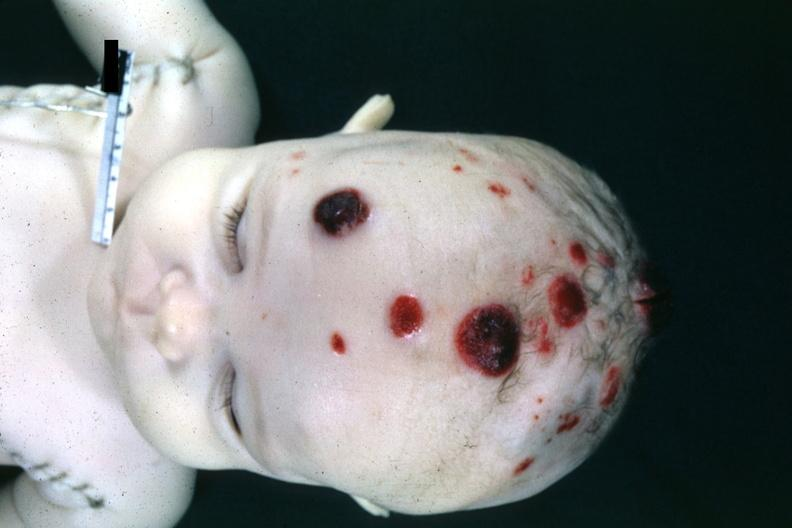s coronary atherosclerosis present?
Answer the question using a single word or phrase. No 